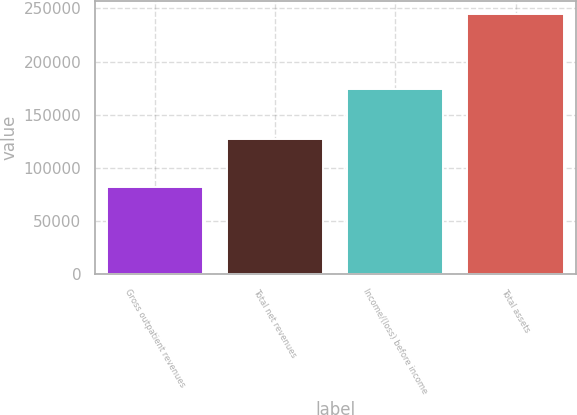Convert chart to OTSL. <chart><loc_0><loc_0><loc_500><loc_500><bar_chart><fcel>Gross outpatient revenues<fcel>Total net revenues<fcel>Income/(loss) before income<fcel>Total assets<nl><fcel>82208<fcel>126704<fcel>173962<fcel>244780<nl></chart> 